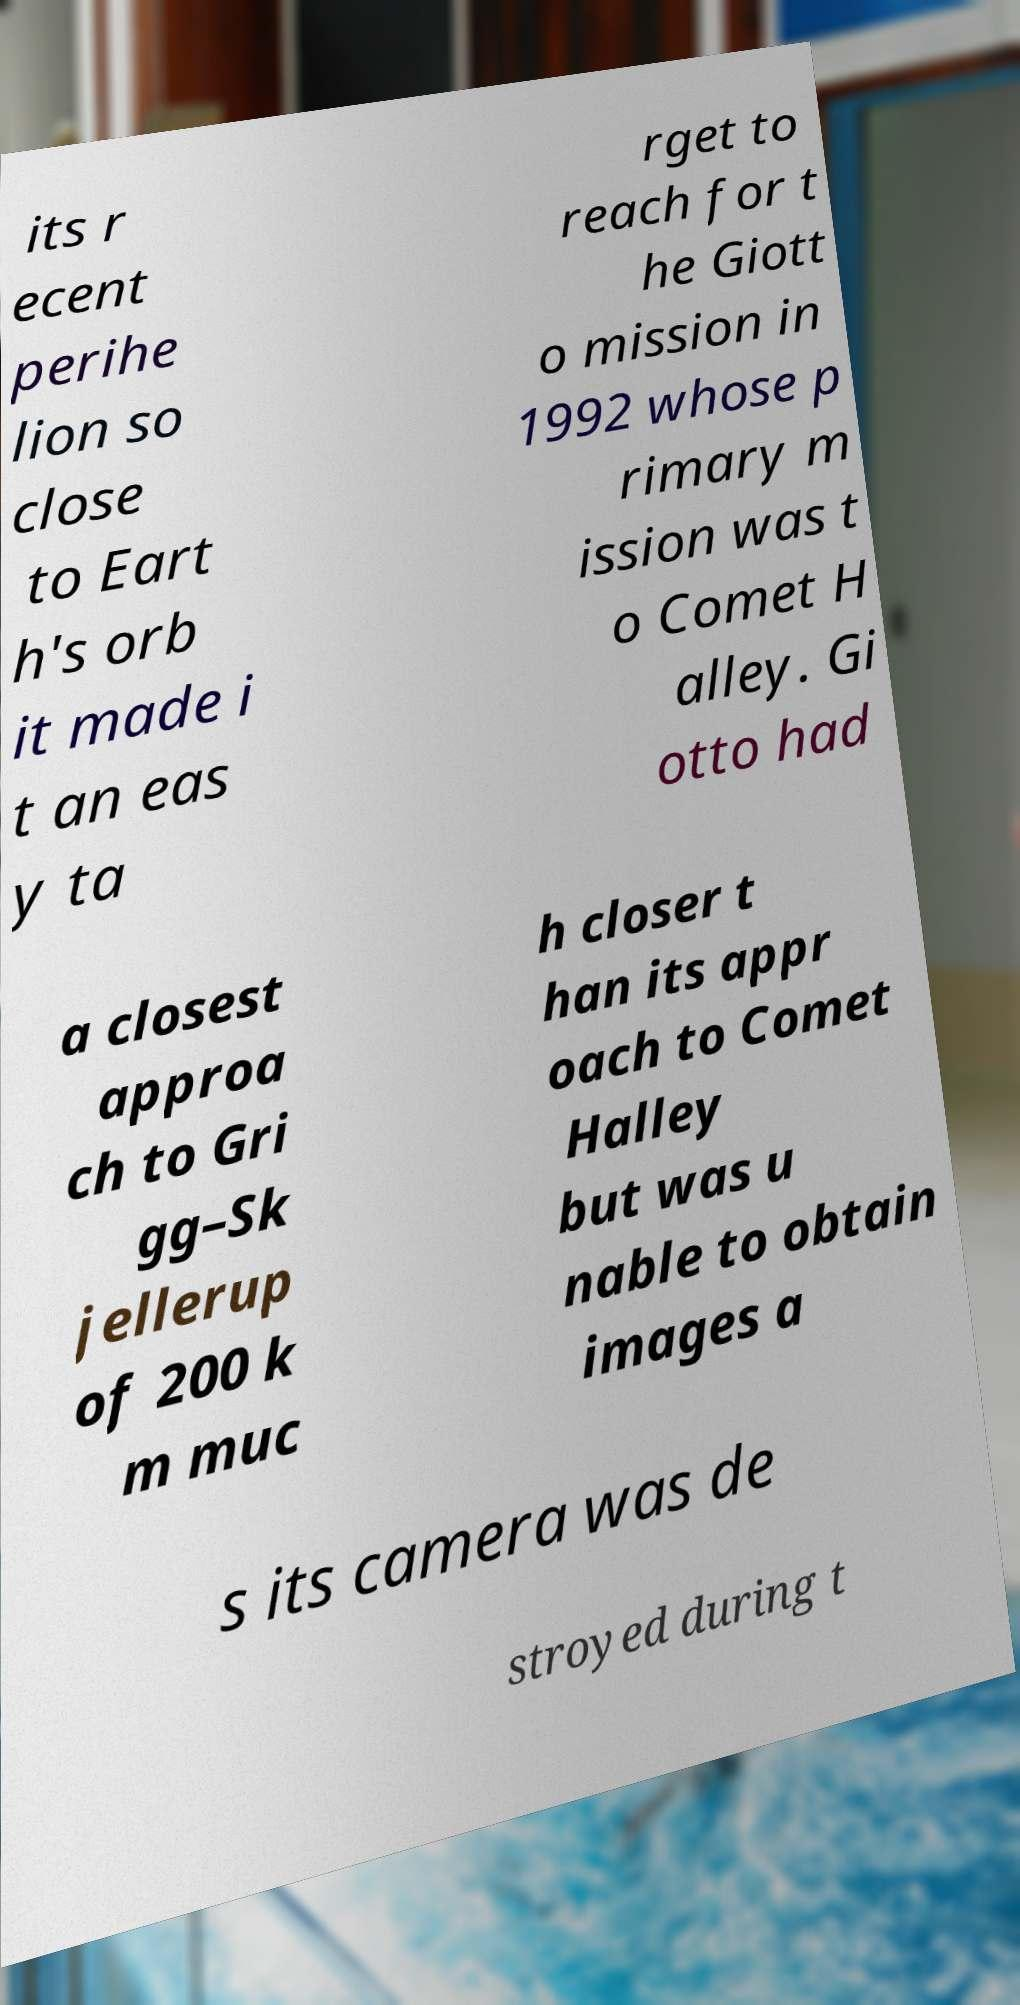Could you extract and type out the text from this image? its r ecent perihe lion so close to Eart h's orb it made i t an eas y ta rget to reach for t he Giott o mission in 1992 whose p rimary m ission was t o Comet H alley. Gi otto had a closest approa ch to Gri gg–Sk jellerup of 200 k m muc h closer t han its appr oach to Comet Halley but was u nable to obtain images a s its camera was de stroyed during t 